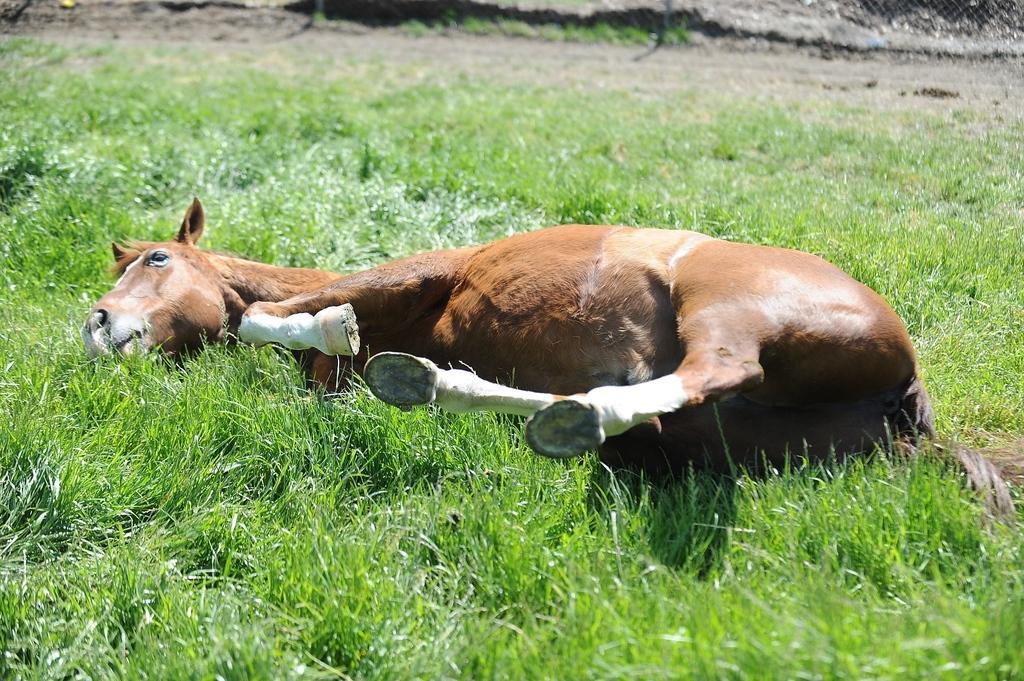Please provide a concise description of this image. In this image in the front there's grass on the ground and in the center there is a horse laying on the ground. 